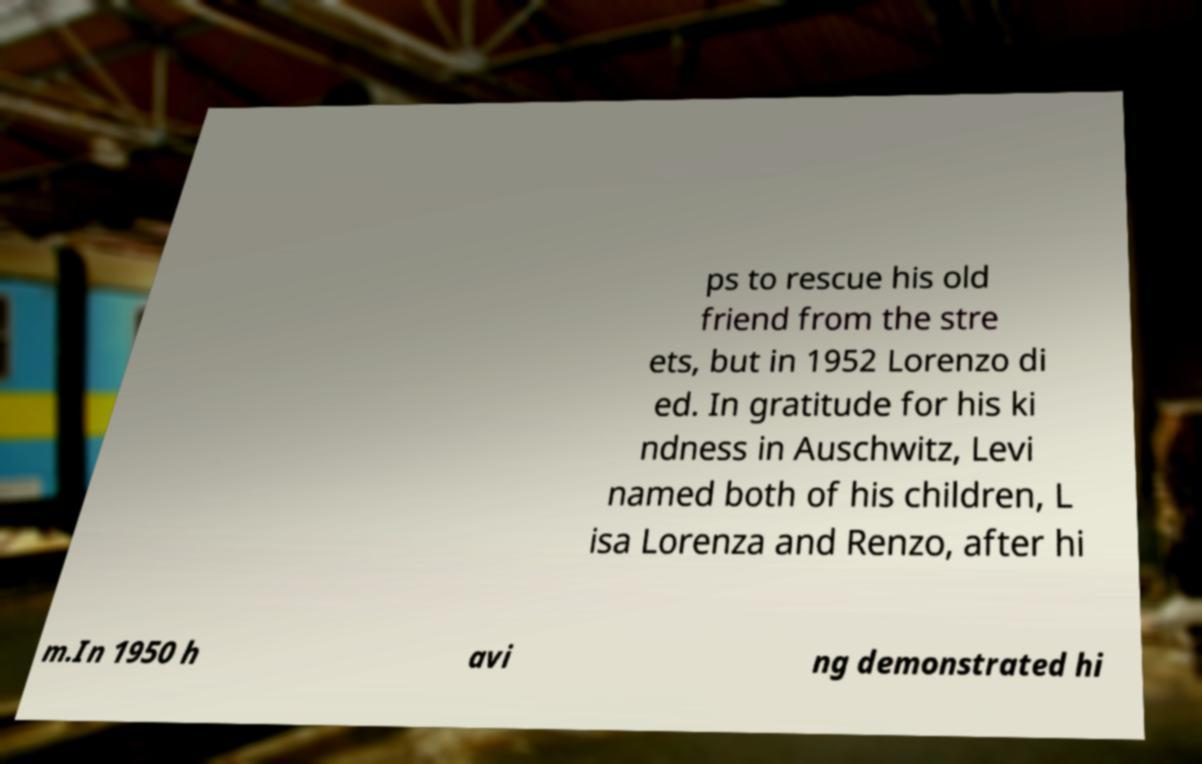I need the written content from this picture converted into text. Can you do that? ps to rescue his old friend from the stre ets, but in 1952 Lorenzo di ed. In gratitude for his ki ndness in Auschwitz, Levi named both of his children, L isa Lorenza and Renzo, after hi m.In 1950 h avi ng demonstrated hi 